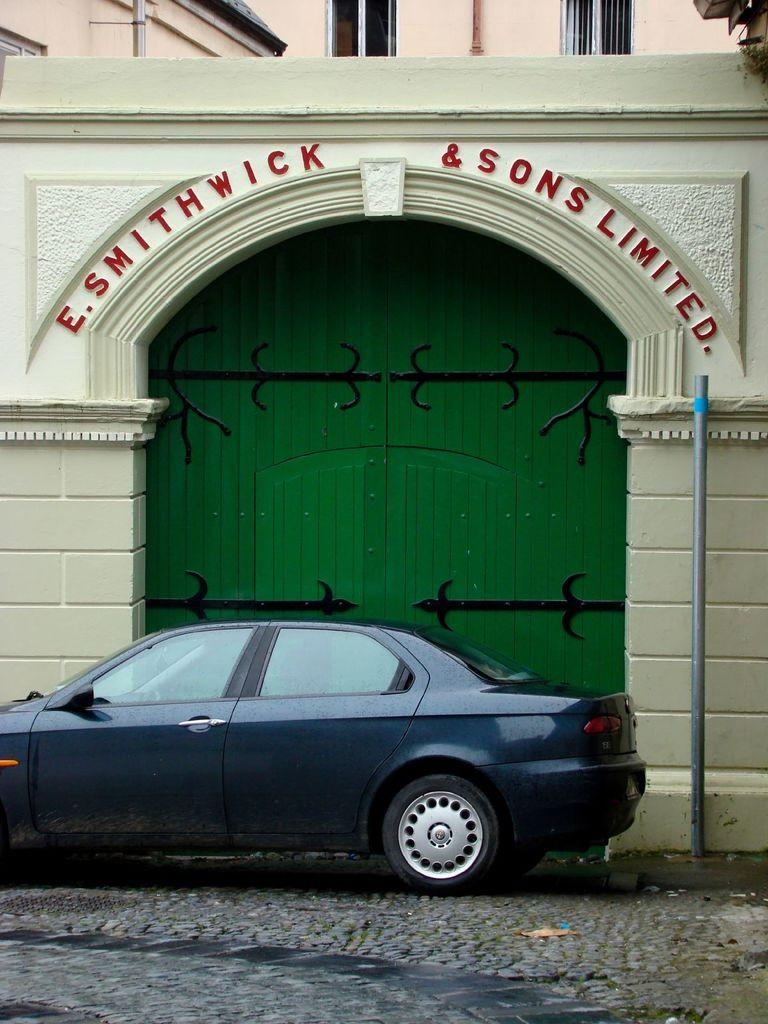What color is the vehicle in the image? The vehicle in the image is blue. What can be seen in the background of the image? There is a green color gate, a pole, and a building visible in the background. How many frogs are sitting on the elbow of the building in the image? There are no frogs or elbows present on the building in the image. 